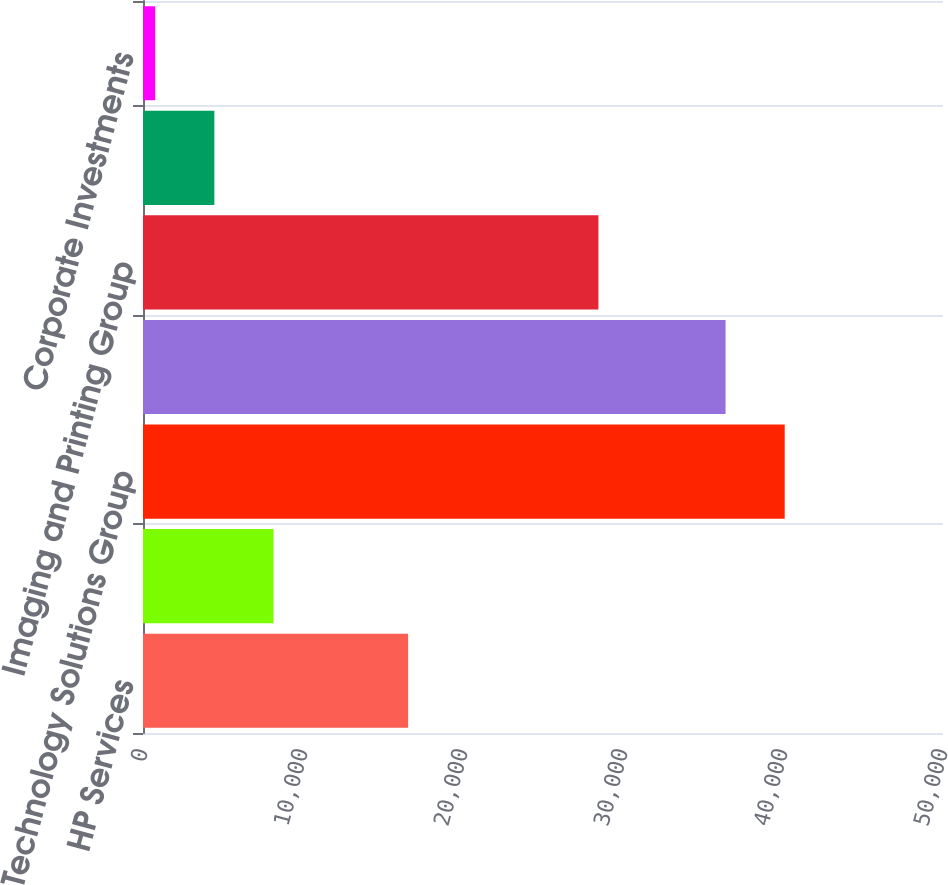<chart> <loc_0><loc_0><loc_500><loc_500><bar_chart><fcel>HP Services<fcel>HP Software<fcel>Technology Solutions Group<fcel>Personal Systems Group<fcel>Imaging and Printing Group<fcel>HP Financial Services<fcel>Corporate Investments<nl><fcel>16570<fcel>8157.6<fcel>40106.8<fcel>36409<fcel>28465<fcel>4459.8<fcel>762<nl></chart> 